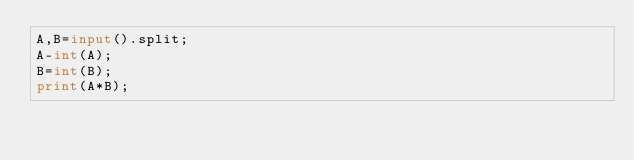<code> <loc_0><loc_0><loc_500><loc_500><_Python_>A,B=input().split;
A-int(A);
B=int(B);
print(A*B);</code> 